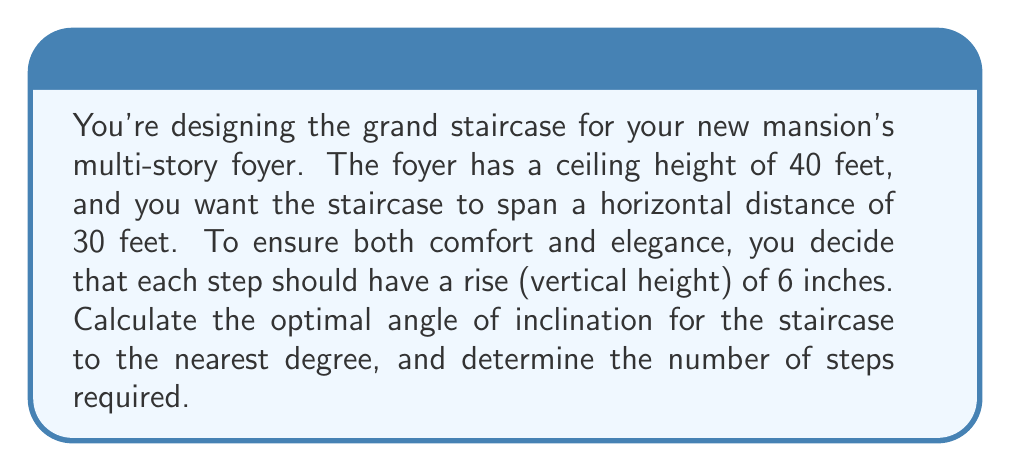Teach me how to tackle this problem. Let's approach this step-by-step:

1) First, we need to calculate the total rise of the staircase:
   $40 \text{ feet} = 480 \text{ inches}$

2) We know each step has a rise of 6 inches. To find the number of steps:
   $\text{Number of steps} = \frac{\text{Total rise}}{\text{Rise per step}} = \frac{480}{6} = 80 \text{ steps}$

3) Now, we can use trigonometry to find the angle of inclination. We'll use the tangent function:

   $$\tan(\theta) = \frac{\text{opposite}}{\text{adjacent}} = \frac{\text{rise}}{\text{run}}$$

4) We know the total rise (40 feet) and the horizontal span (30 feet):

   $$\tan(\theta) = \frac{40}{30} = \frac{4}{3} \approx 1.333$$

5) To find the angle, we use the inverse tangent (arctangent) function:

   $$\theta = \arctan(1.333) \approx 53.13^\circ$$

6) Rounding to the nearest degree:
   $\theta \approx 53^\circ$

[asy]
import geometry;

size(200);
draw((0,0)--(100,0), arrow=Arrow(TeXHead));
draw((0,0)--(0,133), arrow=Arrow(TeXHead));
draw((0,0)--(100,133));

label("30 ft", (50,-10));
label("40 ft", (-10,66.5));
label("$\theta$", (10,10));

dot((0,0));
dot((100,133));
[/asy]
Answer: The optimal angle of inclination for the staircase is approximately $53^\circ$, and it will require 80 steps. 